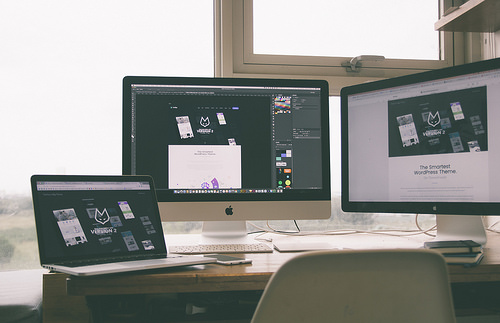<image>
Is the laptop next to the desktop? Yes. The laptop is positioned adjacent to the desktop, located nearby in the same general area. 